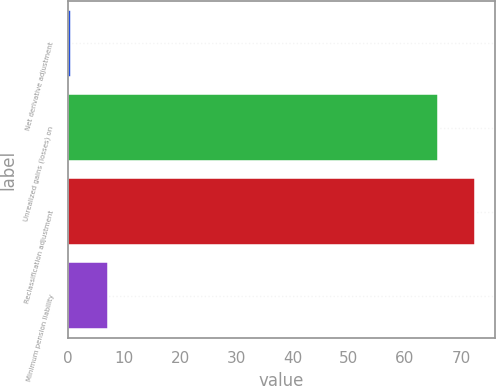Convert chart. <chart><loc_0><loc_0><loc_500><loc_500><bar_chart><fcel>Net derivative adjustment<fcel>Unrealized gains (losses) on<fcel>Reclassification adjustment<fcel>Minimum pension liability<nl><fcel>0.5<fcel>65.9<fcel>72.47<fcel>7.07<nl></chart> 